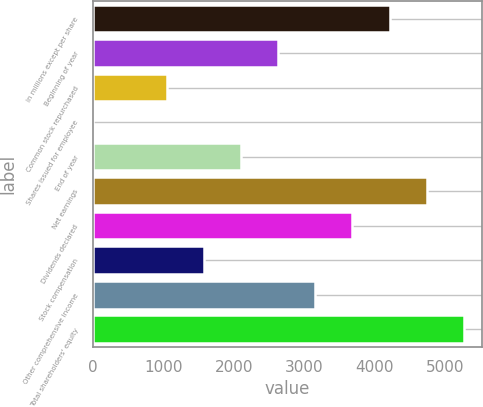Convert chart. <chart><loc_0><loc_0><loc_500><loc_500><bar_chart><fcel>in millions except per share<fcel>Beginning of year<fcel>Common stock repurchased<fcel>Shares issued for employee<fcel>End of year<fcel>Net earnings<fcel>Dividends declared<fcel>Stock compensation<fcel>Other comprehensive income<fcel>Total shareholders' equity<nl><fcel>4207.4<fcel>2630<fcel>1052.6<fcel>1<fcel>2104.2<fcel>4733.2<fcel>3681.6<fcel>1578.4<fcel>3155.8<fcel>5259<nl></chart> 